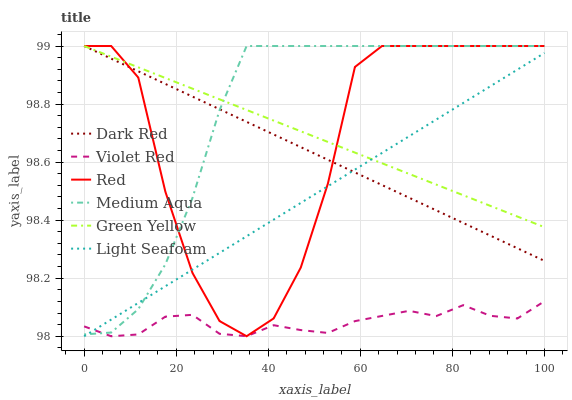Does Violet Red have the minimum area under the curve?
Answer yes or no. Yes. Does Medium Aqua have the maximum area under the curve?
Answer yes or no. Yes. Does Green Yellow have the minimum area under the curve?
Answer yes or no. No. Does Green Yellow have the maximum area under the curve?
Answer yes or no. No. Is Dark Red the smoothest?
Answer yes or no. Yes. Is Red the roughest?
Answer yes or no. Yes. Is Green Yellow the smoothest?
Answer yes or no. No. Is Green Yellow the roughest?
Answer yes or no. No. Does Violet Red have the lowest value?
Answer yes or no. Yes. Does Dark Red have the lowest value?
Answer yes or no. No. Does Red have the highest value?
Answer yes or no. Yes. Does Light Seafoam have the highest value?
Answer yes or no. No. Is Violet Red less than Green Yellow?
Answer yes or no. Yes. Is Green Yellow greater than Violet Red?
Answer yes or no. Yes. Does Light Seafoam intersect Green Yellow?
Answer yes or no. Yes. Is Light Seafoam less than Green Yellow?
Answer yes or no. No. Is Light Seafoam greater than Green Yellow?
Answer yes or no. No. Does Violet Red intersect Green Yellow?
Answer yes or no. No. 